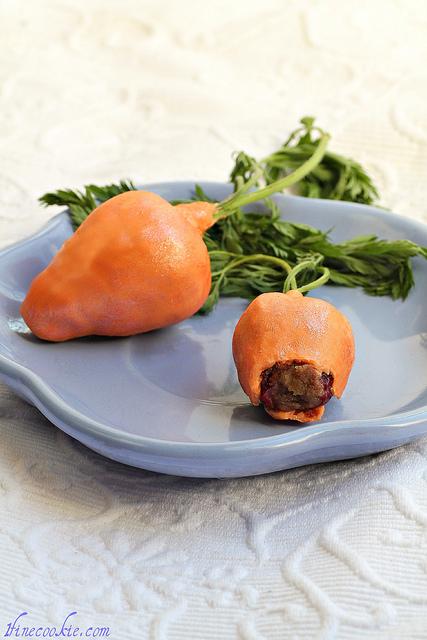What food is shown?
Keep it brief. Carrot. Are these real carrots?
Give a very brief answer. No. Is it salad pizza?
Give a very brief answer. No. Has this food been bitten into yet?
Concise answer only. Yes. What color is the dish?
Short answer required. Blue. 